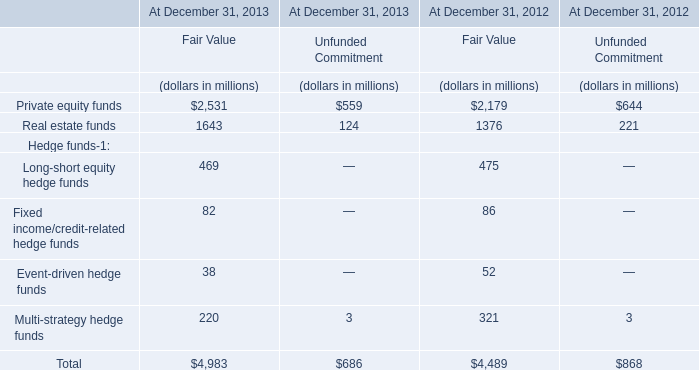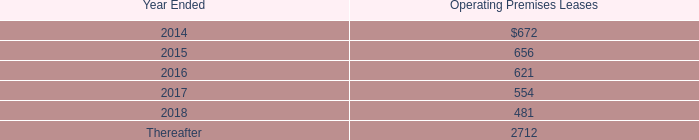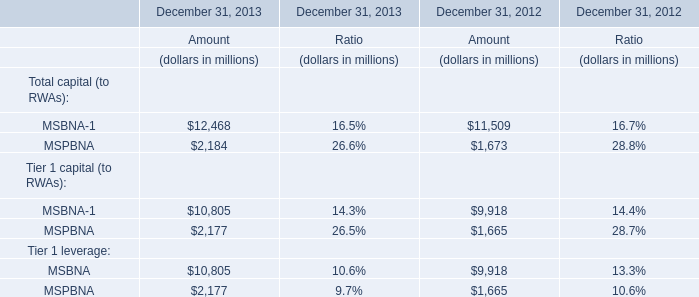What's the increasing rate of MSBNA-1 for Total capital (to RWAs) in 2013? 
Computations: ((12468 - 11509) / 11509)
Answer: 0.08333. 